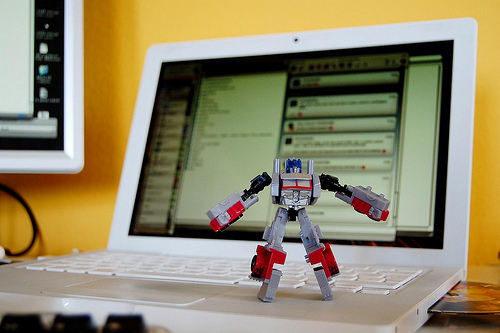<image>
Is there a toy on the laptop? Yes. Looking at the image, I can see the toy is positioned on top of the laptop, with the laptop providing support. Is the transformer on the computer? Yes. Looking at the image, I can see the transformer is positioned on top of the computer, with the computer providing support. Is there a toy in front of the laptop? No. The toy is not in front of the laptop. The spatial positioning shows a different relationship between these objects. Is the computer above the robot? No. The computer is not positioned above the robot. The vertical arrangement shows a different relationship. 